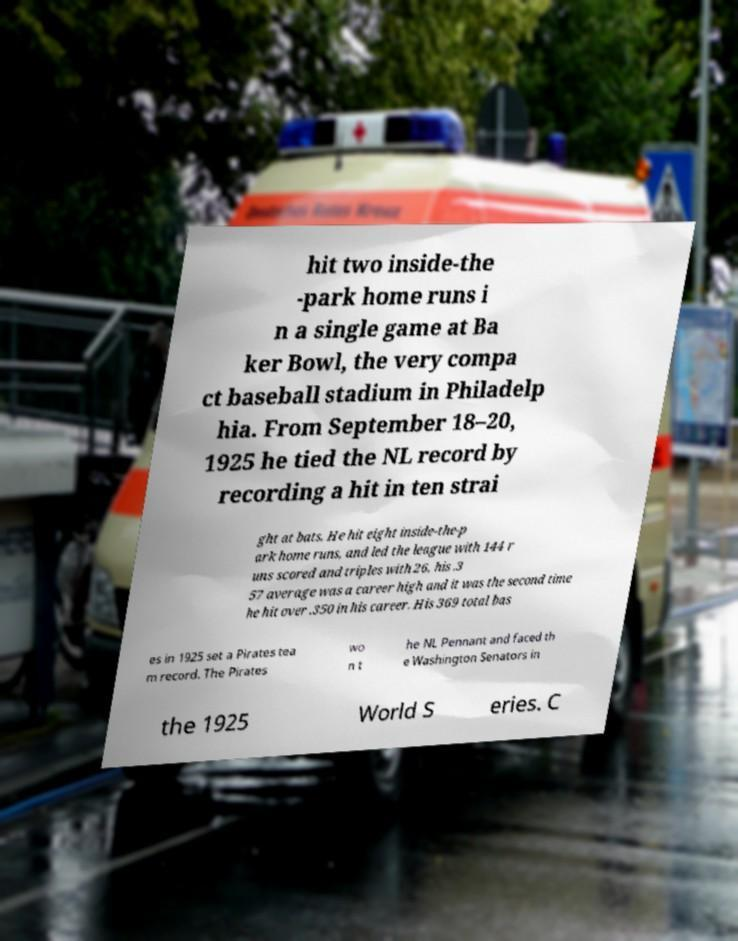Please read and relay the text visible in this image. What does it say? hit two inside-the -park home runs i n a single game at Ba ker Bowl, the very compa ct baseball stadium in Philadelp hia. From September 18–20, 1925 he tied the NL record by recording a hit in ten strai ght at bats. He hit eight inside-the-p ark home runs, and led the league with 144 r uns scored and triples with 26, his .3 57 average was a career high and it was the second time he hit over .350 in his career. His 369 total bas es in 1925 set a Pirates tea m record. The Pirates wo n t he NL Pennant and faced th e Washington Senators in the 1925 World S eries. C 